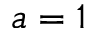Convert formula to latex. <formula><loc_0><loc_0><loc_500><loc_500>a = 1</formula> 